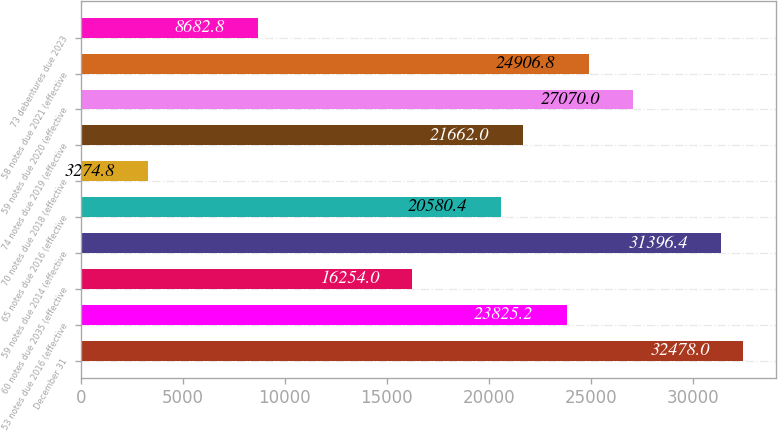Convert chart. <chart><loc_0><loc_0><loc_500><loc_500><bar_chart><fcel>December 31<fcel>53 notes due 2016 (effective<fcel>60 notes due 2035 (effective<fcel>59 notes due 2014 (effective<fcel>65 notes due 2016 (effective<fcel>70 notes due 2018 (effective<fcel>74 notes due 2019 (effective<fcel>59 notes due 2020 (effective<fcel>58 notes due 2021 (effective<fcel>73 debentures due 2023<nl><fcel>32478<fcel>23825.2<fcel>16254<fcel>31396.4<fcel>20580.4<fcel>3274.8<fcel>21662<fcel>27070<fcel>24906.8<fcel>8682.8<nl></chart> 